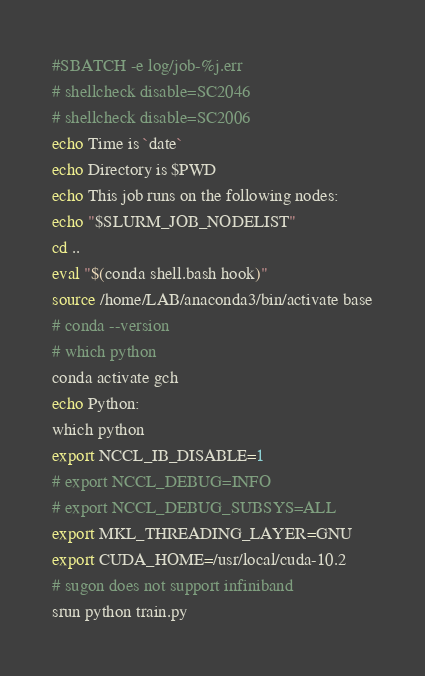<code> <loc_0><loc_0><loc_500><loc_500><_Bash_>#SBATCH -e log/job-%j.err
# shellcheck disable=SC2046
# shellcheck disable=SC2006
echo Time is `date`
echo Directory is $PWD
echo This job runs on the following nodes:
echo "$SLURM_JOB_NODELIST"
cd ..
eval "$(conda shell.bash hook)"
source /home/LAB/anaconda3/bin/activate base
# conda --version
# which python
conda activate gch
echo Python:
which python
export NCCL_IB_DISABLE=1
# export NCCL_DEBUG=INFO
# export NCCL_DEBUG_SUBSYS=ALL
export MKL_THREADING_LAYER=GNU
export CUDA_HOME=/usr/local/cuda-10.2
# sugon does not support infiniband
srun python train.py</code> 